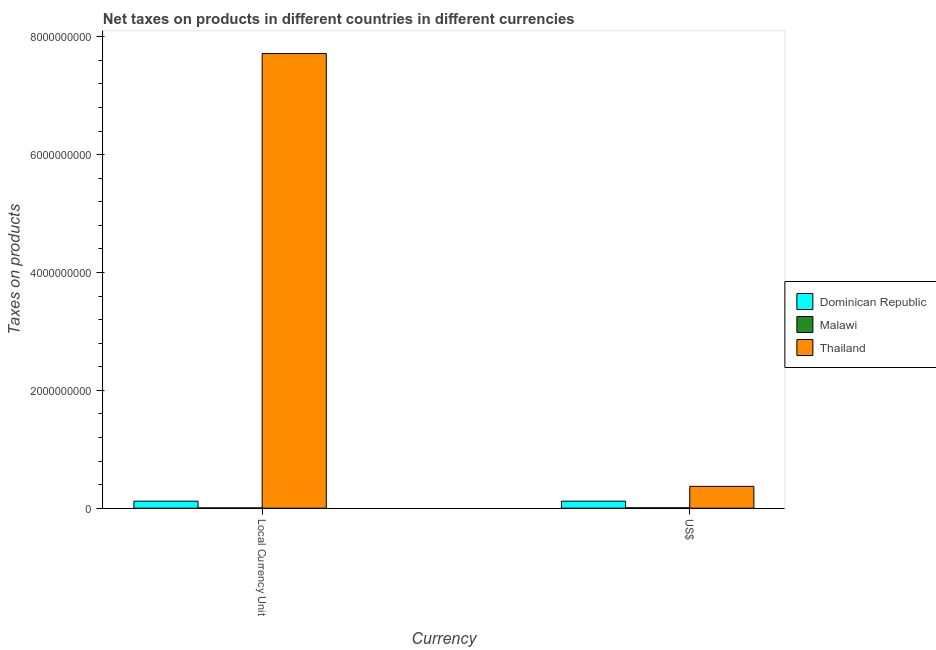How many groups of bars are there?
Keep it short and to the point. 2. How many bars are there on the 2nd tick from the left?
Provide a short and direct response. 3. What is the label of the 1st group of bars from the left?
Give a very brief answer. Local Currency Unit. What is the net taxes in us$ in Dominican Republic?
Your answer should be compact. 1.19e+08. Across all countries, what is the maximum net taxes in constant 2005 us$?
Provide a succinct answer. 7.71e+09. Across all countries, what is the minimum net taxes in constant 2005 us$?
Offer a very short reply. 4.60e+06. In which country was the net taxes in constant 2005 us$ maximum?
Make the answer very short. Thailand. In which country was the net taxes in constant 2005 us$ minimum?
Give a very brief answer. Malawi. What is the total net taxes in us$ in the graph?
Give a very brief answer. 4.96e+08. What is the difference between the net taxes in us$ in Malawi and that in Thailand?
Your response must be concise. -3.64e+08. What is the difference between the net taxes in constant 2005 us$ in Malawi and the net taxes in us$ in Thailand?
Offer a very short reply. -3.66e+08. What is the average net taxes in us$ per country?
Provide a short and direct response. 1.65e+08. What is the difference between the net taxes in constant 2005 us$ and net taxes in us$ in Malawi?
Make the answer very short. -1.84e+06. What is the ratio of the net taxes in constant 2005 us$ in Thailand to that in Dominican Republic?
Ensure brevity in your answer.  64.72. What does the 3rd bar from the left in US$ represents?
Provide a short and direct response. Thailand. What does the 1st bar from the right in US$ represents?
Your answer should be compact. Thailand. How many bars are there?
Offer a very short reply. 6. What is the difference between two consecutive major ticks on the Y-axis?
Ensure brevity in your answer.  2.00e+09. Does the graph contain any zero values?
Your response must be concise. No. Does the graph contain grids?
Your response must be concise. No. Where does the legend appear in the graph?
Make the answer very short. Center right. How many legend labels are there?
Make the answer very short. 3. What is the title of the graph?
Make the answer very short. Net taxes on products in different countries in different currencies. Does "Hong Kong" appear as one of the legend labels in the graph?
Make the answer very short. No. What is the label or title of the X-axis?
Your answer should be very brief. Currency. What is the label or title of the Y-axis?
Keep it short and to the point. Taxes on products. What is the Taxes on products in Dominican Republic in Local Currency Unit?
Your answer should be very brief. 1.19e+08. What is the Taxes on products in Malawi in Local Currency Unit?
Keep it short and to the point. 4.60e+06. What is the Taxes on products in Thailand in Local Currency Unit?
Offer a terse response. 7.71e+09. What is the Taxes on products in Dominican Republic in US$?
Keep it short and to the point. 1.19e+08. What is the Taxes on products in Malawi in US$?
Your response must be concise. 6.44e+06. What is the Taxes on products of Thailand in US$?
Offer a very short reply. 3.70e+08. Across all Currency, what is the maximum Taxes on products of Dominican Republic?
Keep it short and to the point. 1.19e+08. Across all Currency, what is the maximum Taxes on products in Malawi?
Provide a short and direct response. 6.44e+06. Across all Currency, what is the maximum Taxes on products in Thailand?
Your response must be concise. 7.71e+09. Across all Currency, what is the minimum Taxes on products of Dominican Republic?
Keep it short and to the point. 1.19e+08. Across all Currency, what is the minimum Taxes on products of Malawi?
Your answer should be compact. 4.60e+06. Across all Currency, what is the minimum Taxes on products of Thailand?
Give a very brief answer. 3.70e+08. What is the total Taxes on products of Dominican Republic in the graph?
Make the answer very short. 2.38e+08. What is the total Taxes on products in Malawi in the graph?
Ensure brevity in your answer.  1.10e+07. What is the total Taxes on products of Thailand in the graph?
Provide a short and direct response. 8.08e+09. What is the difference between the Taxes on products of Dominican Republic in Local Currency Unit and that in US$?
Your answer should be very brief. 0. What is the difference between the Taxes on products of Malawi in Local Currency Unit and that in US$?
Make the answer very short. -1.84e+06. What is the difference between the Taxes on products of Thailand in Local Currency Unit and that in US$?
Your response must be concise. 7.34e+09. What is the difference between the Taxes on products of Dominican Republic in Local Currency Unit and the Taxes on products of Malawi in US$?
Offer a terse response. 1.13e+08. What is the difference between the Taxes on products of Dominican Republic in Local Currency Unit and the Taxes on products of Thailand in US$?
Keep it short and to the point. -2.51e+08. What is the difference between the Taxes on products of Malawi in Local Currency Unit and the Taxes on products of Thailand in US$?
Offer a terse response. -3.66e+08. What is the average Taxes on products in Dominican Republic per Currency?
Your response must be concise. 1.19e+08. What is the average Taxes on products in Malawi per Currency?
Offer a terse response. 5.52e+06. What is the average Taxes on products of Thailand per Currency?
Offer a terse response. 4.04e+09. What is the difference between the Taxes on products in Dominican Republic and Taxes on products in Malawi in Local Currency Unit?
Your answer should be very brief. 1.15e+08. What is the difference between the Taxes on products in Dominican Republic and Taxes on products in Thailand in Local Currency Unit?
Make the answer very short. -7.60e+09. What is the difference between the Taxes on products in Malawi and Taxes on products in Thailand in Local Currency Unit?
Make the answer very short. -7.71e+09. What is the difference between the Taxes on products of Dominican Republic and Taxes on products of Malawi in US$?
Offer a very short reply. 1.13e+08. What is the difference between the Taxes on products in Dominican Republic and Taxes on products in Thailand in US$?
Ensure brevity in your answer.  -2.51e+08. What is the difference between the Taxes on products in Malawi and Taxes on products in Thailand in US$?
Provide a short and direct response. -3.64e+08. What is the ratio of the Taxes on products of Thailand in Local Currency Unit to that in US$?
Your response must be concise. 20.83. What is the difference between the highest and the second highest Taxes on products in Dominican Republic?
Keep it short and to the point. 0. What is the difference between the highest and the second highest Taxes on products of Malawi?
Ensure brevity in your answer.  1.84e+06. What is the difference between the highest and the second highest Taxes on products of Thailand?
Provide a succinct answer. 7.34e+09. What is the difference between the highest and the lowest Taxes on products of Malawi?
Make the answer very short. 1.84e+06. What is the difference between the highest and the lowest Taxes on products in Thailand?
Give a very brief answer. 7.34e+09. 